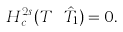<formula> <loc_0><loc_0><loc_500><loc_500>H ^ { 2 s } _ { c } ( T \ \hat { T } _ { 1 } ) = 0 .</formula> 